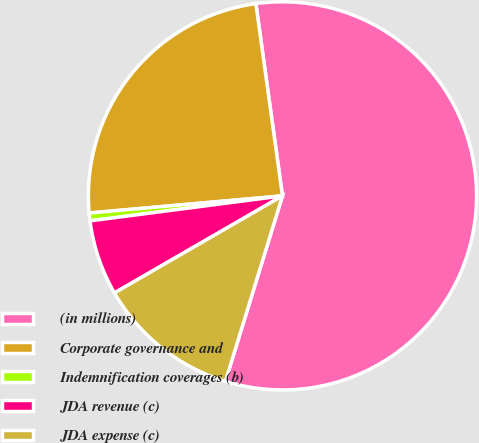Convert chart to OTSL. <chart><loc_0><loc_0><loc_500><loc_500><pie_chart><fcel>(in millions)<fcel>Corporate governance and<fcel>Indemnification coverages (b)<fcel>JDA revenue (c)<fcel>JDA expense (c)<nl><fcel>56.94%<fcel>24.22%<fcel>0.65%<fcel>6.28%<fcel>11.91%<nl></chart> 